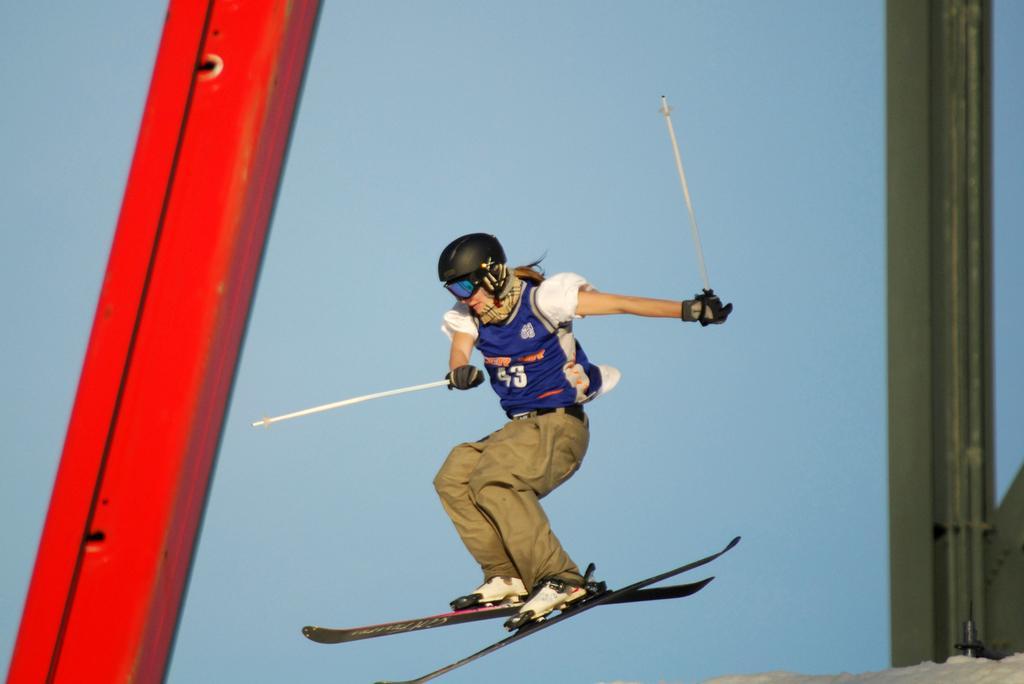Could you give a brief overview of what you see in this image? In this image, we can see a person wearing ski boards and holding sticks with her hands. There is a metal pole on the left and on the right side of the image. 